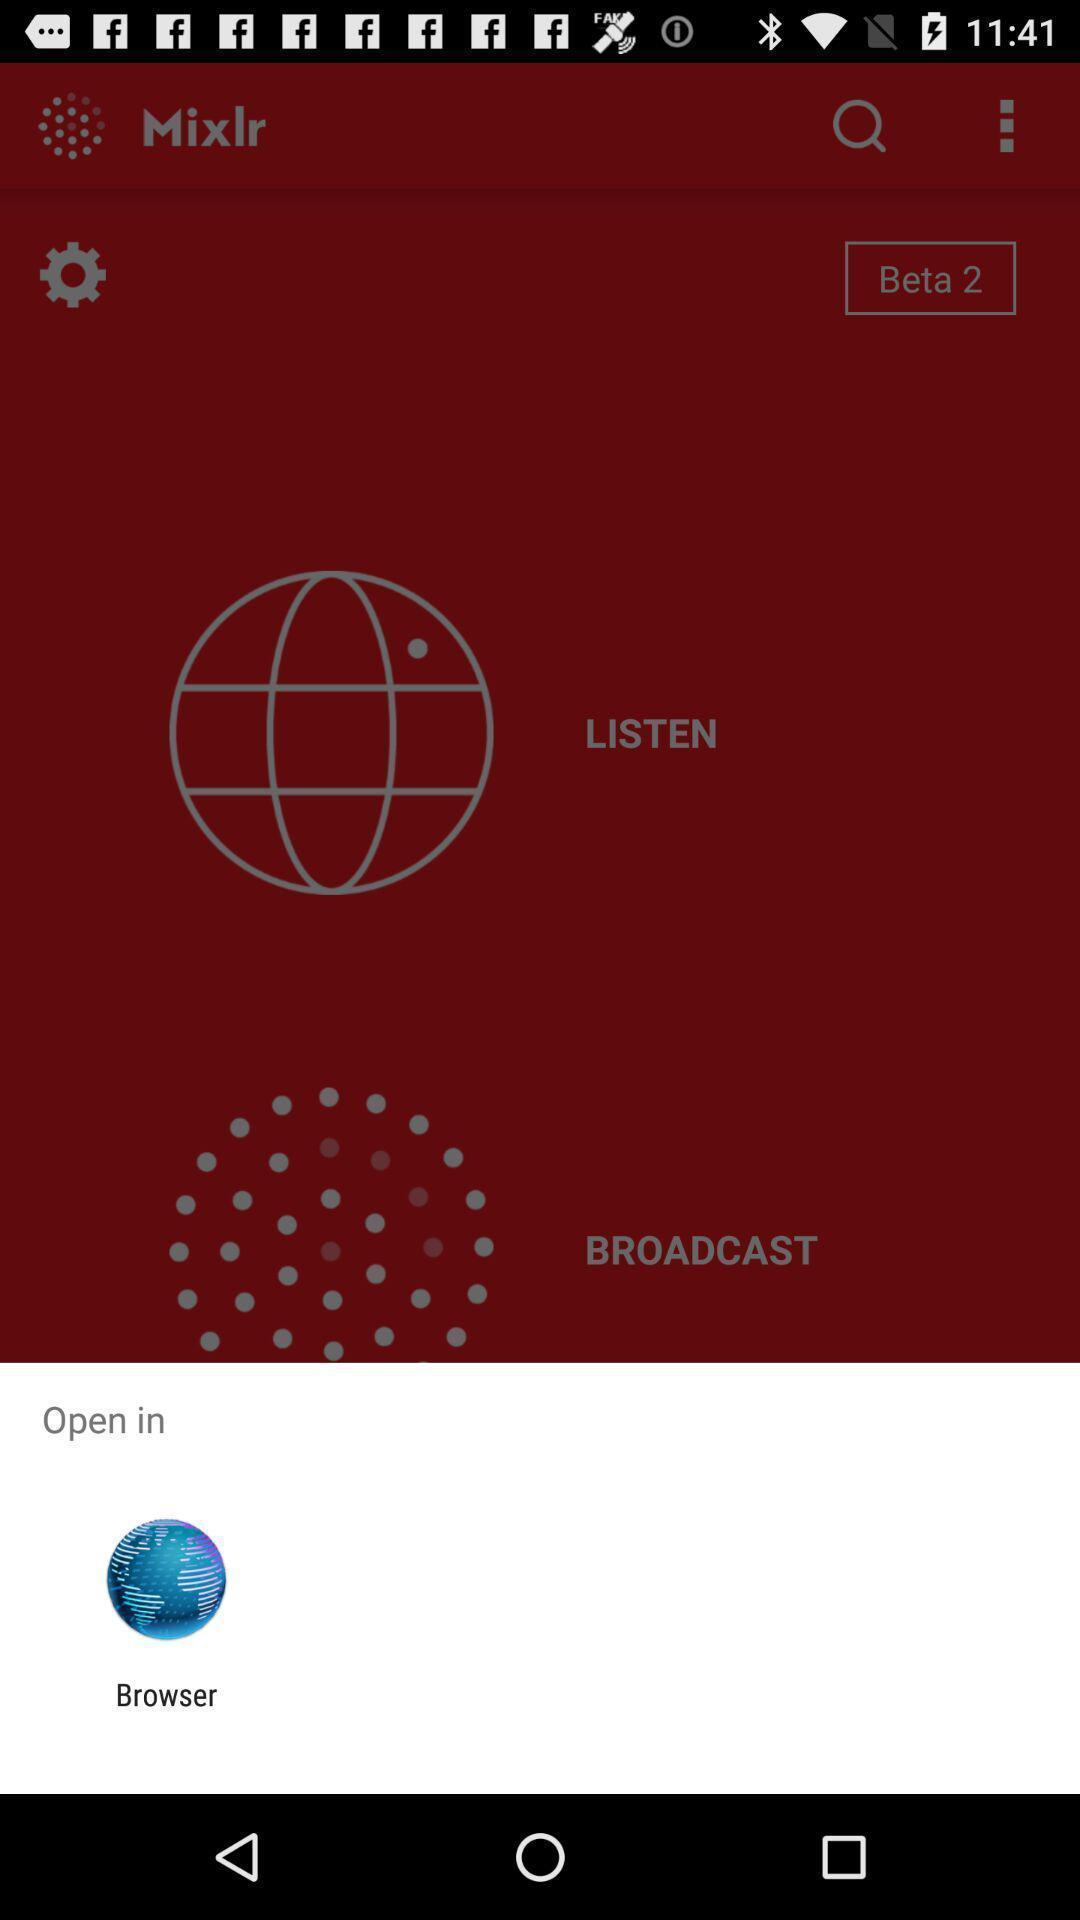Summarize the information in this screenshot. Popup displaying an application to open a file with. 